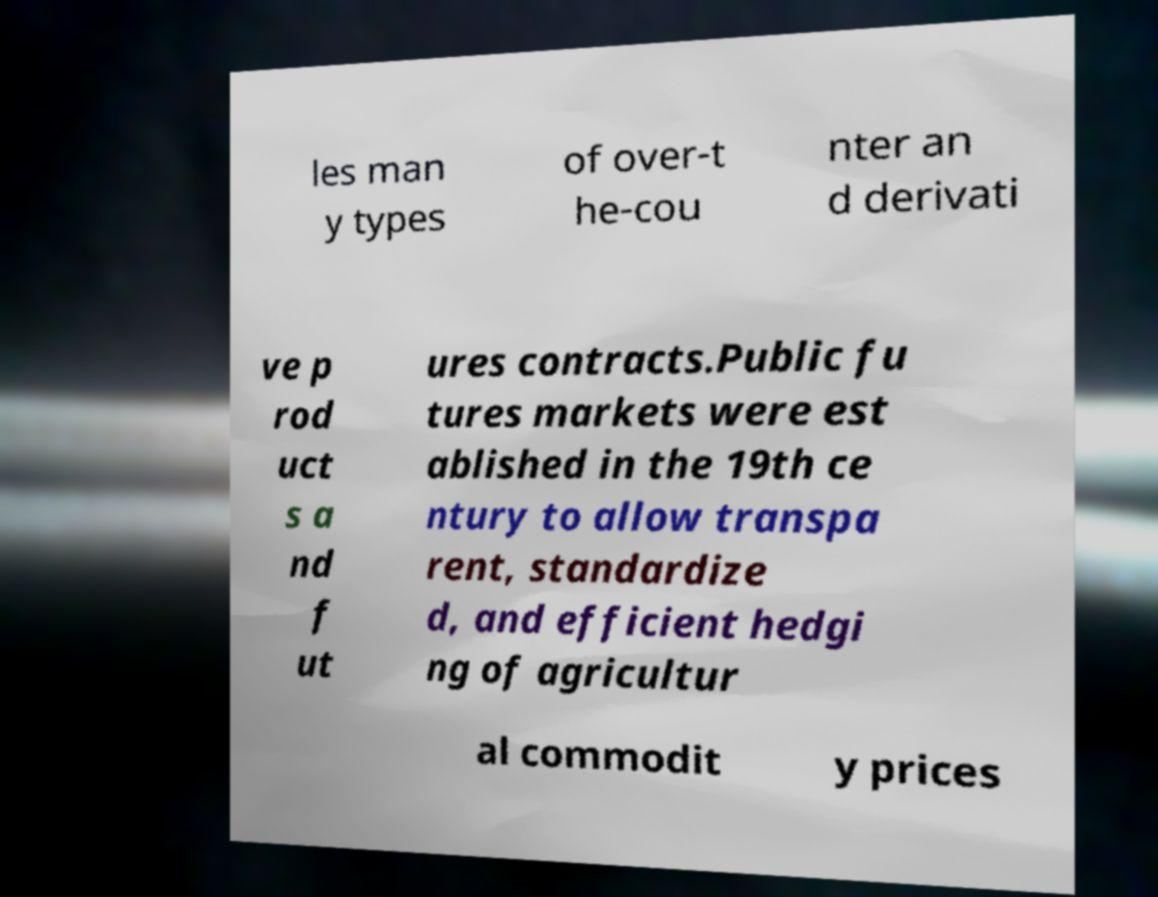For documentation purposes, I need the text within this image transcribed. Could you provide that? les man y types of over-t he-cou nter an d derivati ve p rod uct s a nd f ut ures contracts.Public fu tures markets were est ablished in the 19th ce ntury to allow transpa rent, standardize d, and efficient hedgi ng of agricultur al commodit y prices 